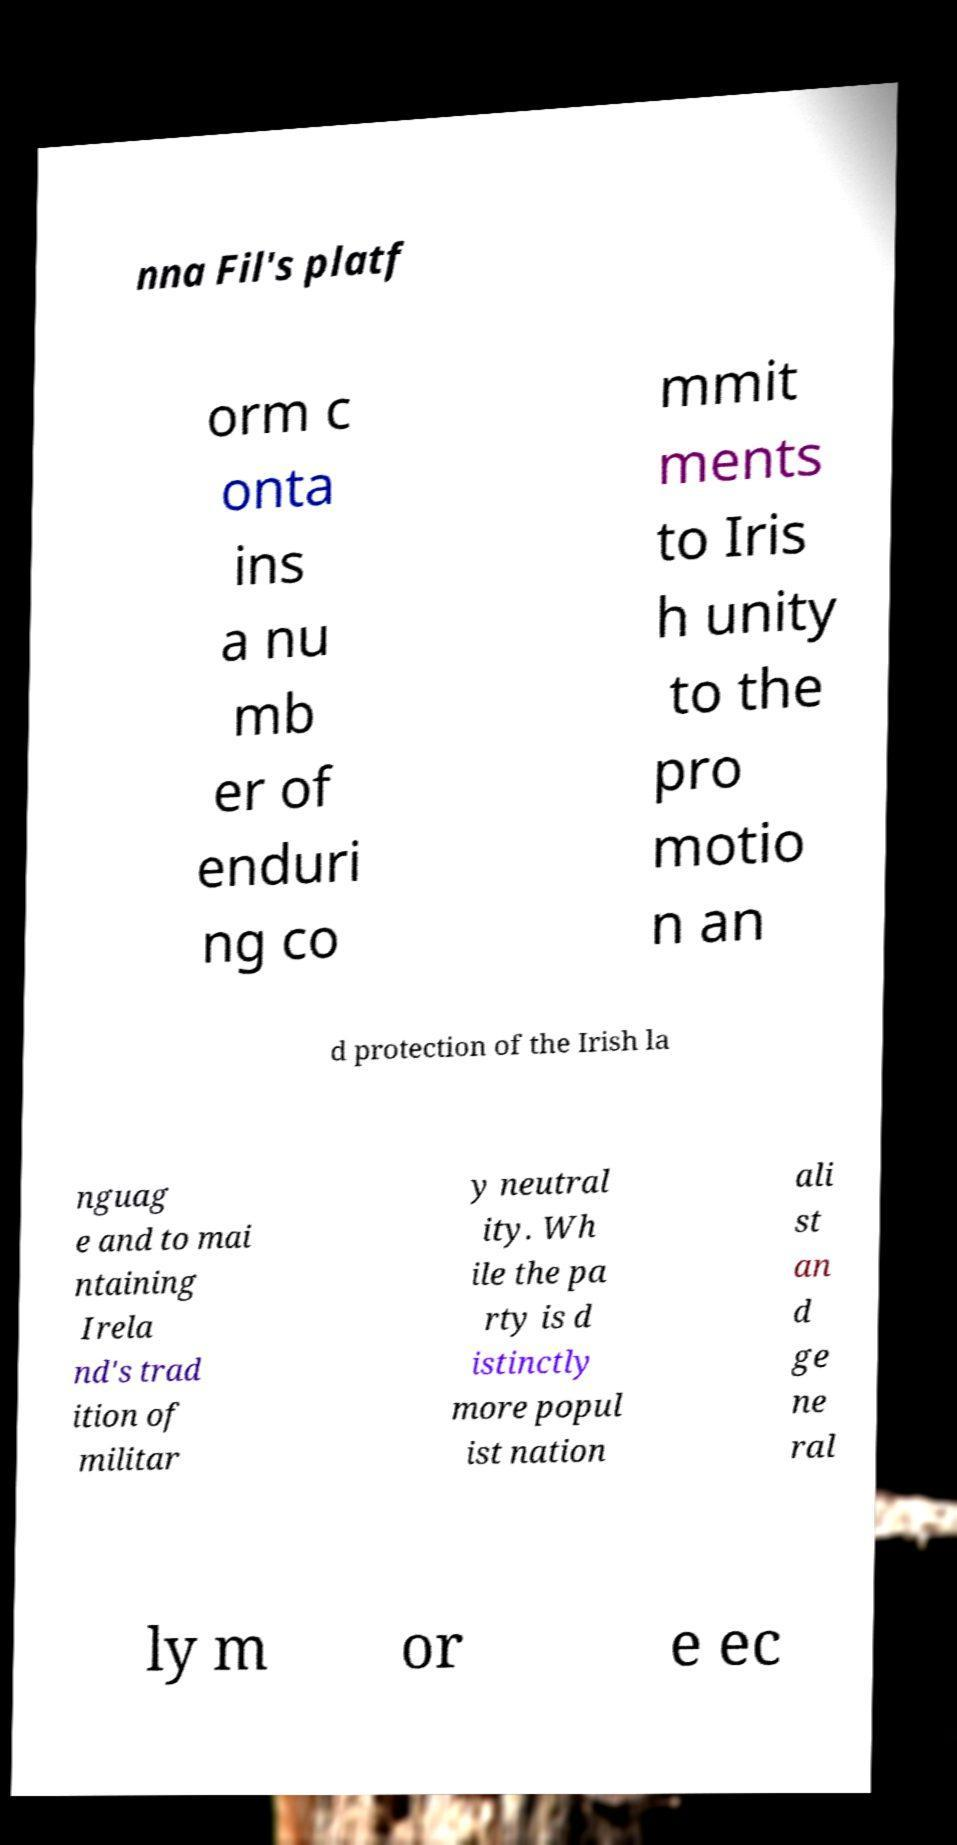Could you assist in decoding the text presented in this image and type it out clearly? nna Fil's platf orm c onta ins a nu mb er of enduri ng co mmit ments to Iris h unity to the pro motio n an d protection of the Irish la nguag e and to mai ntaining Irela nd's trad ition of militar y neutral ity. Wh ile the pa rty is d istinctly more popul ist nation ali st an d ge ne ral ly m or e ec 